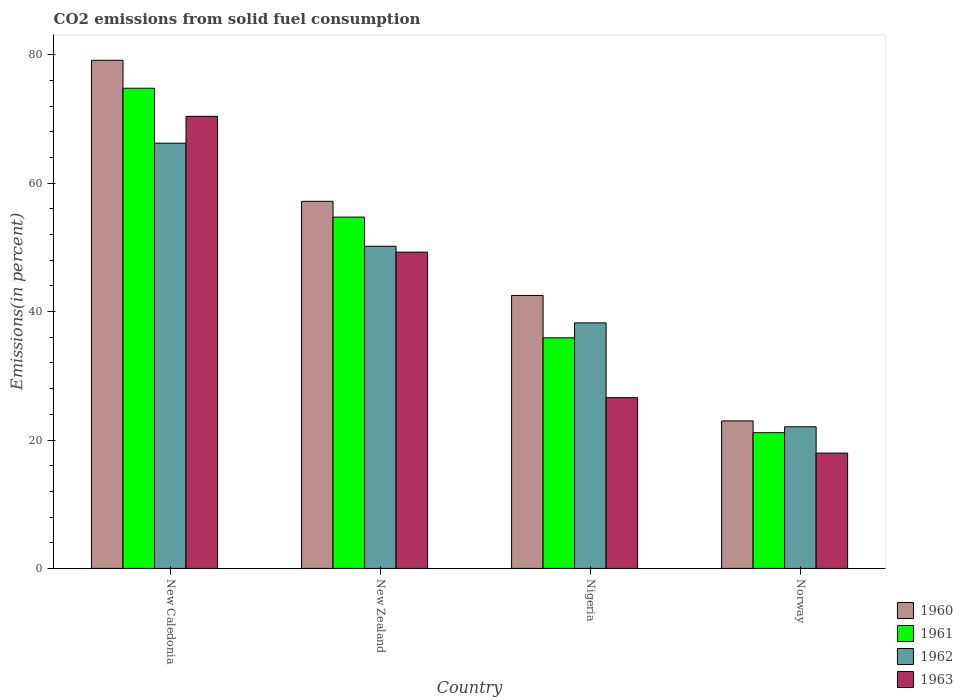How many groups of bars are there?
Make the answer very short. 4. Are the number of bars on each tick of the X-axis equal?
Give a very brief answer. Yes. How many bars are there on the 4th tick from the left?
Your answer should be very brief. 4. How many bars are there on the 2nd tick from the right?
Your answer should be compact. 4. What is the label of the 1st group of bars from the left?
Keep it short and to the point. New Caledonia. In how many cases, is the number of bars for a given country not equal to the number of legend labels?
Provide a short and direct response. 0. What is the total CO2 emitted in 1962 in Norway?
Your answer should be very brief. 22.06. Across all countries, what is the maximum total CO2 emitted in 1961?
Your response must be concise. 74.79. Across all countries, what is the minimum total CO2 emitted in 1963?
Your answer should be compact. 17.96. In which country was the total CO2 emitted in 1960 maximum?
Offer a terse response. New Caledonia. What is the total total CO2 emitted in 1961 in the graph?
Offer a terse response. 186.58. What is the difference between the total CO2 emitted in 1961 in Nigeria and that in Norway?
Ensure brevity in your answer.  14.77. What is the difference between the total CO2 emitted in 1960 in Norway and the total CO2 emitted in 1961 in New Caledonia?
Give a very brief answer. -51.82. What is the average total CO2 emitted in 1960 per country?
Provide a short and direct response. 50.46. What is the difference between the total CO2 emitted of/in 1960 and total CO2 emitted of/in 1962 in New Caledonia?
Your answer should be compact. 12.92. In how many countries, is the total CO2 emitted in 1963 greater than 44 %?
Provide a short and direct response. 2. What is the ratio of the total CO2 emitted in 1963 in New Zealand to that in Norway?
Ensure brevity in your answer.  2.74. What is the difference between the highest and the second highest total CO2 emitted in 1961?
Provide a succinct answer. 38.88. What is the difference between the highest and the lowest total CO2 emitted in 1963?
Ensure brevity in your answer.  52.45. In how many countries, is the total CO2 emitted in 1963 greater than the average total CO2 emitted in 1963 taken over all countries?
Your answer should be very brief. 2. What does the 1st bar from the left in Norway represents?
Offer a very short reply. 1960. What does the 4th bar from the right in New Zealand represents?
Make the answer very short. 1960. Are all the bars in the graph horizontal?
Your answer should be compact. No. What is the difference between two consecutive major ticks on the Y-axis?
Make the answer very short. 20. Does the graph contain any zero values?
Ensure brevity in your answer.  No. Does the graph contain grids?
Provide a succinct answer. No. Where does the legend appear in the graph?
Offer a terse response. Bottom right. How many legend labels are there?
Keep it short and to the point. 4. How are the legend labels stacked?
Make the answer very short. Vertical. What is the title of the graph?
Offer a very short reply. CO2 emissions from solid fuel consumption. What is the label or title of the Y-axis?
Give a very brief answer. Emissions(in percent). What is the Emissions(in percent) of 1960 in New Caledonia?
Offer a very short reply. 79.15. What is the Emissions(in percent) of 1961 in New Caledonia?
Offer a terse response. 74.79. What is the Emissions(in percent) of 1962 in New Caledonia?
Offer a very short reply. 66.23. What is the Emissions(in percent) in 1963 in New Caledonia?
Ensure brevity in your answer.  70.41. What is the Emissions(in percent) of 1960 in New Zealand?
Offer a very short reply. 57.18. What is the Emissions(in percent) of 1961 in New Zealand?
Offer a terse response. 54.72. What is the Emissions(in percent) of 1962 in New Zealand?
Your answer should be very brief. 50.18. What is the Emissions(in percent) of 1963 in New Zealand?
Make the answer very short. 49.27. What is the Emissions(in percent) in 1960 in Nigeria?
Your answer should be compact. 42.52. What is the Emissions(in percent) of 1961 in Nigeria?
Offer a terse response. 35.92. What is the Emissions(in percent) of 1962 in Nigeria?
Ensure brevity in your answer.  38.25. What is the Emissions(in percent) of 1963 in Nigeria?
Your answer should be very brief. 26.59. What is the Emissions(in percent) of 1960 in Norway?
Keep it short and to the point. 22.98. What is the Emissions(in percent) in 1961 in Norway?
Your answer should be very brief. 21.15. What is the Emissions(in percent) in 1962 in Norway?
Provide a short and direct response. 22.06. What is the Emissions(in percent) of 1963 in Norway?
Your answer should be very brief. 17.96. Across all countries, what is the maximum Emissions(in percent) of 1960?
Provide a succinct answer. 79.15. Across all countries, what is the maximum Emissions(in percent) of 1961?
Offer a very short reply. 74.79. Across all countries, what is the maximum Emissions(in percent) in 1962?
Make the answer very short. 66.23. Across all countries, what is the maximum Emissions(in percent) in 1963?
Your response must be concise. 70.41. Across all countries, what is the minimum Emissions(in percent) of 1960?
Keep it short and to the point. 22.98. Across all countries, what is the minimum Emissions(in percent) in 1961?
Make the answer very short. 21.15. Across all countries, what is the minimum Emissions(in percent) in 1962?
Give a very brief answer. 22.06. Across all countries, what is the minimum Emissions(in percent) in 1963?
Provide a short and direct response. 17.96. What is the total Emissions(in percent) in 1960 in the graph?
Offer a very short reply. 201.82. What is the total Emissions(in percent) in 1961 in the graph?
Offer a terse response. 186.58. What is the total Emissions(in percent) of 1962 in the graph?
Offer a terse response. 176.72. What is the total Emissions(in percent) of 1963 in the graph?
Give a very brief answer. 164.24. What is the difference between the Emissions(in percent) of 1960 in New Caledonia and that in New Zealand?
Make the answer very short. 21.97. What is the difference between the Emissions(in percent) in 1961 in New Caledonia and that in New Zealand?
Your answer should be compact. 20.07. What is the difference between the Emissions(in percent) of 1962 in New Caledonia and that in New Zealand?
Provide a succinct answer. 16.05. What is the difference between the Emissions(in percent) in 1963 in New Caledonia and that in New Zealand?
Your answer should be very brief. 21.15. What is the difference between the Emissions(in percent) in 1960 in New Caledonia and that in Nigeria?
Make the answer very short. 36.63. What is the difference between the Emissions(in percent) of 1961 in New Caledonia and that in Nigeria?
Your answer should be compact. 38.88. What is the difference between the Emissions(in percent) of 1962 in New Caledonia and that in Nigeria?
Keep it short and to the point. 27.99. What is the difference between the Emissions(in percent) of 1963 in New Caledonia and that in Nigeria?
Keep it short and to the point. 43.82. What is the difference between the Emissions(in percent) of 1960 in New Caledonia and that in Norway?
Make the answer very short. 56.17. What is the difference between the Emissions(in percent) in 1961 in New Caledonia and that in Norway?
Your answer should be very brief. 53.65. What is the difference between the Emissions(in percent) in 1962 in New Caledonia and that in Norway?
Provide a succinct answer. 44.17. What is the difference between the Emissions(in percent) of 1963 in New Caledonia and that in Norway?
Provide a short and direct response. 52.45. What is the difference between the Emissions(in percent) in 1960 in New Zealand and that in Nigeria?
Keep it short and to the point. 14.66. What is the difference between the Emissions(in percent) of 1961 in New Zealand and that in Nigeria?
Provide a short and direct response. 18.8. What is the difference between the Emissions(in percent) of 1962 in New Zealand and that in Nigeria?
Offer a very short reply. 11.93. What is the difference between the Emissions(in percent) of 1963 in New Zealand and that in Nigeria?
Ensure brevity in your answer.  22.67. What is the difference between the Emissions(in percent) in 1960 in New Zealand and that in Norway?
Make the answer very short. 34.2. What is the difference between the Emissions(in percent) in 1961 in New Zealand and that in Norway?
Make the answer very short. 33.57. What is the difference between the Emissions(in percent) of 1962 in New Zealand and that in Norway?
Give a very brief answer. 28.12. What is the difference between the Emissions(in percent) of 1963 in New Zealand and that in Norway?
Offer a terse response. 31.3. What is the difference between the Emissions(in percent) in 1960 in Nigeria and that in Norway?
Offer a very short reply. 19.54. What is the difference between the Emissions(in percent) in 1961 in Nigeria and that in Norway?
Offer a very short reply. 14.77. What is the difference between the Emissions(in percent) in 1962 in Nigeria and that in Norway?
Provide a succinct answer. 16.18. What is the difference between the Emissions(in percent) of 1963 in Nigeria and that in Norway?
Your response must be concise. 8.63. What is the difference between the Emissions(in percent) of 1960 in New Caledonia and the Emissions(in percent) of 1961 in New Zealand?
Your response must be concise. 24.43. What is the difference between the Emissions(in percent) in 1960 in New Caledonia and the Emissions(in percent) in 1962 in New Zealand?
Your answer should be very brief. 28.97. What is the difference between the Emissions(in percent) in 1960 in New Caledonia and the Emissions(in percent) in 1963 in New Zealand?
Keep it short and to the point. 29.88. What is the difference between the Emissions(in percent) of 1961 in New Caledonia and the Emissions(in percent) of 1962 in New Zealand?
Provide a short and direct response. 24.61. What is the difference between the Emissions(in percent) of 1961 in New Caledonia and the Emissions(in percent) of 1963 in New Zealand?
Offer a terse response. 25.53. What is the difference between the Emissions(in percent) in 1962 in New Caledonia and the Emissions(in percent) in 1963 in New Zealand?
Give a very brief answer. 16.97. What is the difference between the Emissions(in percent) in 1960 in New Caledonia and the Emissions(in percent) in 1961 in Nigeria?
Provide a succinct answer. 43.23. What is the difference between the Emissions(in percent) of 1960 in New Caledonia and the Emissions(in percent) of 1962 in Nigeria?
Ensure brevity in your answer.  40.9. What is the difference between the Emissions(in percent) of 1960 in New Caledonia and the Emissions(in percent) of 1963 in Nigeria?
Your answer should be compact. 52.56. What is the difference between the Emissions(in percent) of 1961 in New Caledonia and the Emissions(in percent) of 1962 in Nigeria?
Keep it short and to the point. 36.55. What is the difference between the Emissions(in percent) of 1961 in New Caledonia and the Emissions(in percent) of 1963 in Nigeria?
Your answer should be compact. 48.2. What is the difference between the Emissions(in percent) in 1962 in New Caledonia and the Emissions(in percent) in 1963 in Nigeria?
Keep it short and to the point. 39.64. What is the difference between the Emissions(in percent) in 1960 in New Caledonia and the Emissions(in percent) in 1961 in Norway?
Provide a succinct answer. 58. What is the difference between the Emissions(in percent) of 1960 in New Caledonia and the Emissions(in percent) of 1962 in Norway?
Keep it short and to the point. 57.09. What is the difference between the Emissions(in percent) of 1960 in New Caledonia and the Emissions(in percent) of 1963 in Norway?
Your response must be concise. 61.19. What is the difference between the Emissions(in percent) in 1961 in New Caledonia and the Emissions(in percent) in 1962 in Norway?
Offer a very short reply. 52.73. What is the difference between the Emissions(in percent) in 1961 in New Caledonia and the Emissions(in percent) in 1963 in Norway?
Provide a succinct answer. 56.83. What is the difference between the Emissions(in percent) in 1962 in New Caledonia and the Emissions(in percent) in 1963 in Norway?
Your answer should be very brief. 48.27. What is the difference between the Emissions(in percent) in 1960 in New Zealand and the Emissions(in percent) in 1961 in Nigeria?
Provide a short and direct response. 21.26. What is the difference between the Emissions(in percent) of 1960 in New Zealand and the Emissions(in percent) of 1962 in Nigeria?
Give a very brief answer. 18.93. What is the difference between the Emissions(in percent) of 1960 in New Zealand and the Emissions(in percent) of 1963 in Nigeria?
Make the answer very short. 30.59. What is the difference between the Emissions(in percent) of 1961 in New Zealand and the Emissions(in percent) of 1962 in Nigeria?
Keep it short and to the point. 16.48. What is the difference between the Emissions(in percent) of 1961 in New Zealand and the Emissions(in percent) of 1963 in Nigeria?
Offer a terse response. 28.13. What is the difference between the Emissions(in percent) of 1962 in New Zealand and the Emissions(in percent) of 1963 in Nigeria?
Your response must be concise. 23.59. What is the difference between the Emissions(in percent) in 1960 in New Zealand and the Emissions(in percent) in 1961 in Norway?
Offer a very short reply. 36.03. What is the difference between the Emissions(in percent) in 1960 in New Zealand and the Emissions(in percent) in 1962 in Norway?
Offer a very short reply. 35.12. What is the difference between the Emissions(in percent) in 1960 in New Zealand and the Emissions(in percent) in 1963 in Norway?
Make the answer very short. 39.22. What is the difference between the Emissions(in percent) in 1961 in New Zealand and the Emissions(in percent) in 1962 in Norway?
Provide a succinct answer. 32.66. What is the difference between the Emissions(in percent) of 1961 in New Zealand and the Emissions(in percent) of 1963 in Norway?
Ensure brevity in your answer.  36.76. What is the difference between the Emissions(in percent) in 1962 in New Zealand and the Emissions(in percent) in 1963 in Norway?
Your response must be concise. 32.22. What is the difference between the Emissions(in percent) in 1960 in Nigeria and the Emissions(in percent) in 1961 in Norway?
Offer a terse response. 21.37. What is the difference between the Emissions(in percent) of 1960 in Nigeria and the Emissions(in percent) of 1962 in Norway?
Keep it short and to the point. 20.46. What is the difference between the Emissions(in percent) of 1960 in Nigeria and the Emissions(in percent) of 1963 in Norway?
Provide a short and direct response. 24.56. What is the difference between the Emissions(in percent) in 1961 in Nigeria and the Emissions(in percent) in 1962 in Norway?
Offer a very short reply. 13.86. What is the difference between the Emissions(in percent) in 1961 in Nigeria and the Emissions(in percent) in 1963 in Norway?
Offer a terse response. 17.95. What is the difference between the Emissions(in percent) in 1962 in Nigeria and the Emissions(in percent) in 1963 in Norway?
Your answer should be compact. 20.28. What is the average Emissions(in percent) of 1960 per country?
Your answer should be very brief. 50.46. What is the average Emissions(in percent) in 1961 per country?
Provide a short and direct response. 46.65. What is the average Emissions(in percent) in 1962 per country?
Your answer should be very brief. 44.18. What is the average Emissions(in percent) of 1963 per country?
Keep it short and to the point. 41.06. What is the difference between the Emissions(in percent) of 1960 and Emissions(in percent) of 1961 in New Caledonia?
Your answer should be compact. 4.36. What is the difference between the Emissions(in percent) in 1960 and Emissions(in percent) in 1962 in New Caledonia?
Your response must be concise. 12.92. What is the difference between the Emissions(in percent) of 1960 and Emissions(in percent) of 1963 in New Caledonia?
Ensure brevity in your answer.  8.73. What is the difference between the Emissions(in percent) in 1961 and Emissions(in percent) in 1962 in New Caledonia?
Provide a short and direct response. 8.56. What is the difference between the Emissions(in percent) of 1961 and Emissions(in percent) of 1963 in New Caledonia?
Provide a succinct answer. 4.38. What is the difference between the Emissions(in percent) in 1962 and Emissions(in percent) in 1963 in New Caledonia?
Your answer should be very brief. -4.18. What is the difference between the Emissions(in percent) in 1960 and Emissions(in percent) in 1961 in New Zealand?
Keep it short and to the point. 2.46. What is the difference between the Emissions(in percent) of 1960 and Emissions(in percent) of 1962 in New Zealand?
Offer a very short reply. 7. What is the difference between the Emissions(in percent) of 1960 and Emissions(in percent) of 1963 in New Zealand?
Your answer should be compact. 7.91. What is the difference between the Emissions(in percent) of 1961 and Emissions(in percent) of 1962 in New Zealand?
Your response must be concise. 4.54. What is the difference between the Emissions(in percent) in 1961 and Emissions(in percent) in 1963 in New Zealand?
Offer a very short reply. 5.46. What is the difference between the Emissions(in percent) in 1962 and Emissions(in percent) in 1963 in New Zealand?
Your response must be concise. 0.91. What is the difference between the Emissions(in percent) of 1960 and Emissions(in percent) of 1961 in Nigeria?
Ensure brevity in your answer.  6.6. What is the difference between the Emissions(in percent) in 1960 and Emissions(in percent) in 1962 in Nigeria?
Ensure brevity in your answer.  4.27. What is the difference between the Emissions(in percent) in 1960 and Emissions(in percent) in 1963 in Nigeria?
Keep it short and to the point. 15.93. What is the difference between the Emissions(in percent) in 1961 and Emissions(in percent) in 1962 in Nigeria?
Offer a terse response. -2.33. What is the difference between the Emissions(in percent) of 1961 and Emissions(in percent) of 1963 in Nigeria?
Ensure brevity in your answer.  9.32. What is the difference between the Emissions(in percent) of 1962 and Emissions(in percent) of 1963 in Nigeria?
Ensure brevity in your answer.  11.65. What is the difference between the Emissions(in percent) of 1960 and Emissions(in percent) of 1961 in Norway?
Keep it short and to the point. 1.83. What is the difference between the Emissions(in percent) of 1960 and Emissions(in percent) of 1962 in Norway?
Make the answer very short. 0.91. What is the difference between the Emissions(in percent) of 1960 and Emissions(in percent) of 1963 in Norway?
Keep it short and to the point. 5.01. What is the difference between the Emissions(in percent) of 1961 and Emissions(in percent) of 1962 in Norway?
Give a very brief answer. -0.92. What is the difference between the Emissions(in percent) of 1961 and Emissions(in percent) of 1963 in Norway?
Give a very brief answer. 3.18. What is the difference between the Emissions(in percent) of 1962 and Emissions(in percent) of 1963 in Norway?
Your response must be concise. 4.1. What is the ratio of the Emissions(in percent) of 1960 in New Caledonia to that in New Zealand?
Make the answer very short. 1.38. What is the ratio of the Emissions(in percent) of 1961 in New Caledonia to that in New Zealand?
Your answer should be very brief. 1.37. What is the ratio of the Emissions(in percent) in 1962 in New Caledonia to that in New Zealand?
Your response must be concise. 1.32. What is the ratio of the Emissions(in percent) in 1963 in New Caledonia to that in New Zealand?
Provide a short and direct response. 1.43. What is the ratio of the Emissions(in percent) in 1960 in New Caledonia to that in Nigeria?
Give a very brief answer. 1.86. What is the ratio of the Emissions(in percent) in 1961 in New Caledonia to that in Nigeria?
Provide a succinct answer. 2.08. What is the ratio of the Emissions(in percent) of 1962 in New Caledonia to that in Nigeria?
Your response must be concise. 1.73. What is the ratio of the Emissions(in percent) of 1963 in New Caledonia to that in Nigeria?
Your response must be concise. 2.65. What is the ratio of the Emissions(in percent) of 1960 in New Caledonia to that in Norway?
Give a very brief answer. 3.44. What is the ratio of the Emissions(in percent) in 1961 in New Caledonia to that in Norway?
Provide a succinct answer. 3.54. What is the ratio of the Emissions(in percent) of 1962 in New Caledonia to that in Norway?
Give a very brief answer. 3. What is the ratio of the Emissions(in percent) of 1963 in New Caledonia to that in Norway?
Provide a succinct answer. 3.92. What is the ratio of the Emissions(in percent) in 1960 in New Zealand to that in Nigeria?
Your answer should be very brief. 1.34. What is the ratio of the Emissions(in percent) of 1961 in New Zealand to that in Nigeria?
Your response must be concise. 1.52. What is the ratio of the Emissions(in percent) of 1962 in New Zealand to that in Nigeria?
Ensure brevity in your answer.  1.31. What is the ratio of the Emissions(in percent) in 1963 in New Zealand to that in Nigeria?
Make the answer very short. 1.85. What is the ratio of the Emissions(in percent) of 1960 in New Zealand to that in Norway?
Your response must be concise. 2.49. What is the ratio of the Emissions(in percent) of 1961 in New Zealand to that in Norway?
Your answer should be compact. 2.59. What is the ratio of the Emissions(in percent) in 1962 in New Zealand to that in Norway?
Offer a very short reply. 2.27. What is the ratio of the Emissions(in percent) in 1963 in New Zealand to that in Norway?
Your answer should be compact. 2.74. What is the ratio of the Emissions(in percent) of 1960 in Nigeria to that in Norway?
Provide a short and direct response. 1.85. What is the ratio of the Emissions(in percent) in 1961 in Nigeria to that in Norway?
Make the answer very short. 1.7. What is the ratio of the Emissions(in percent) in 1962 in Nigeria to that in Norway?
Provide a short and direct response. 1.73. What is the ratio of the Emissions(in percent) of 1963 in Nigeria to that in Norway?
Offer a very short reply. 1.48. What is the difference between the highest and the second highest Emissions(in percent) in 1960?
Give a very brief answer. 21.97. What is the difference between the highest and the second highest Emissions(in percent) in 1961?
Ensure brevity in your answer.  20.07. What is the difference between the highest and the second highest Emissions(in percent) of 1962?
Make the answer very short. 16.05. What is the difference between the highest and the second highest Emissions(in percent) in 1963?
Offer a very short reply. 21.15. What is the difference between the highest and the lowest Emissions(in percent) of 1960?
Give a very brief answer. 56.17. What is the difference between the highest and the lowest Emissions(in percent) in 1961?
Offer a very short reply. 53.65. What is the difference between the highest and the lowest Emissions(in percent) of 1962?
Your response must be concise. 44.17. What is the difference between the highest and the lowest Emissions(in percent) of 1963?
Offer a very short reply. 52.45. 